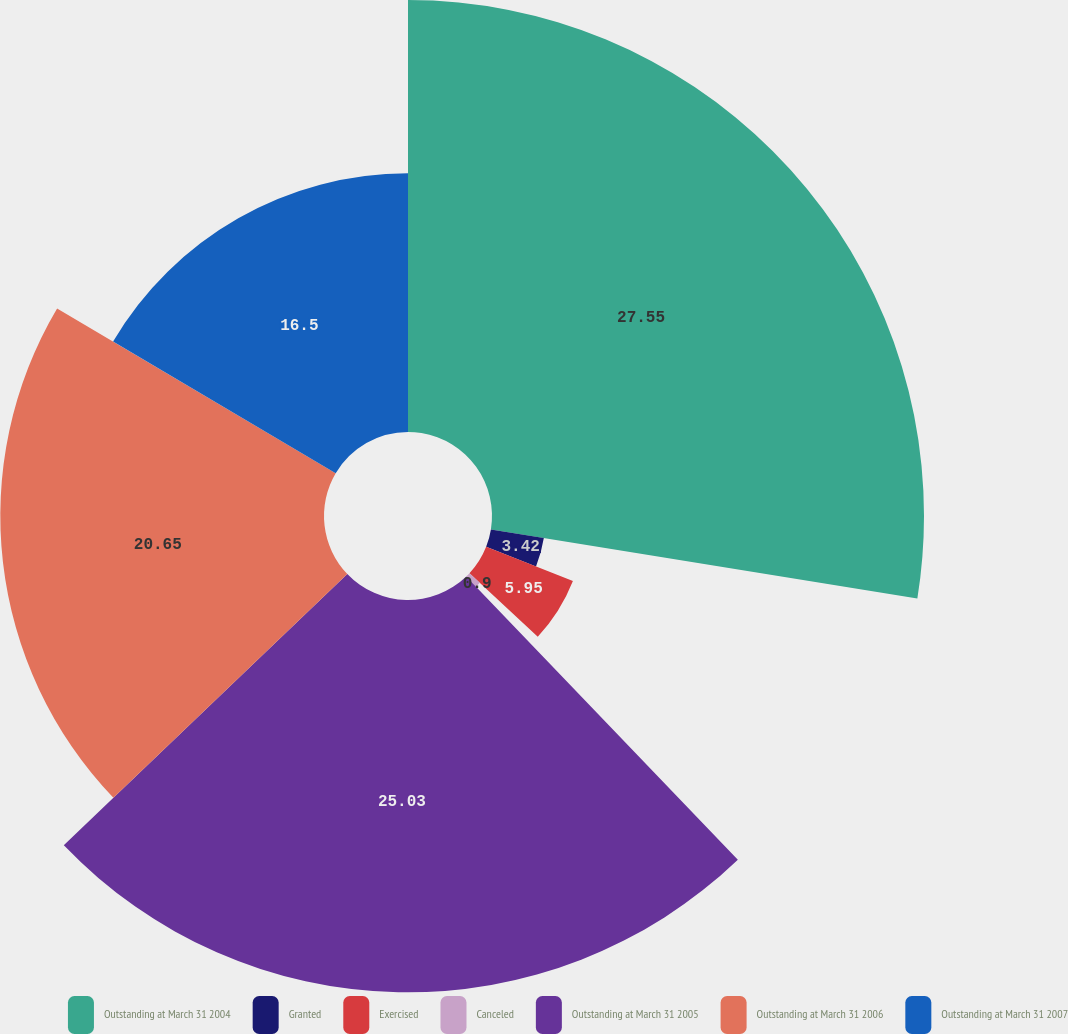Convert chart. <chart><loc_0><loc_0><loc_500><loc_500><pie_chart><fcel>Outstanding at March 31 2004<fcel>Granted<fcel>Exercised<fcel>Canceled<fcel>Outstanding at March 31 2005<fcel>Outstanding at March 31 2006<fcel>Outstanding at March 31 2007<nl><fcel>27.56%<fcel>3.42%<fcel>5.95%<fcel>0.9%<fcel>25.03%<fcel>20.65%<fcel>16.5%<nl></chart> 